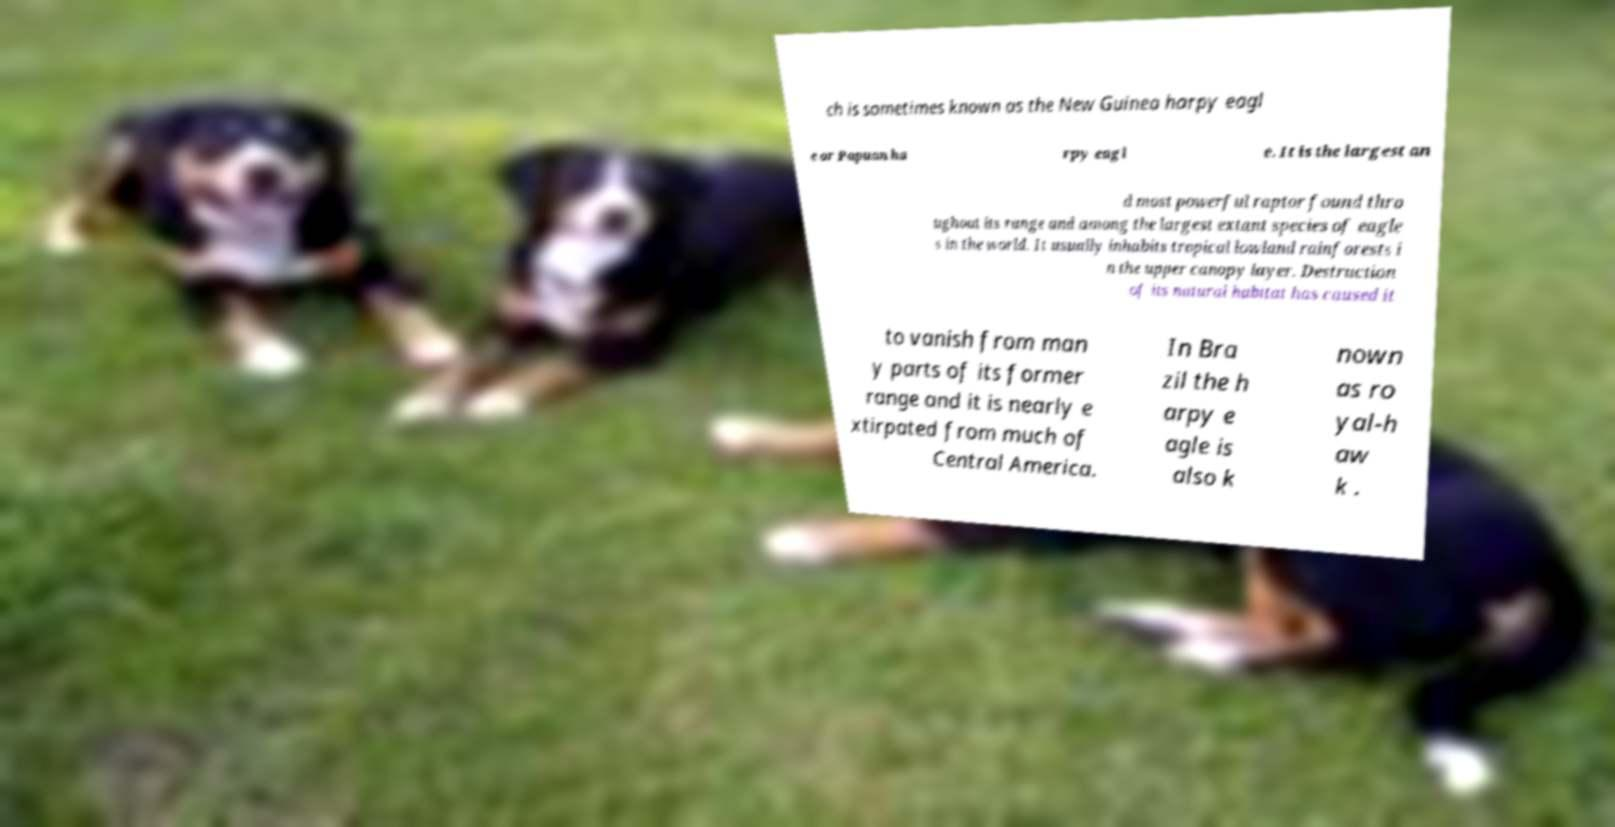For documentation purposes, I need the text within this image transcribed. Could you provide that? ch is sometimes known as the New Guinea harpy eagl e or Papuan ha rpy eagl e. It is the largest an d most powerful raptor found thro ughout its range and among the largest extant species of eagle s in the world. It usually inhabits tropical lowland rainforests i n the upper canopy layer. Destruction of its natural habitat has caused it to vanish from man y parts of its former range and it is nearly e xtirpated from much of Central America. In Bra zil the h arpy e agle is also k nown as ro yal-h aw k . 